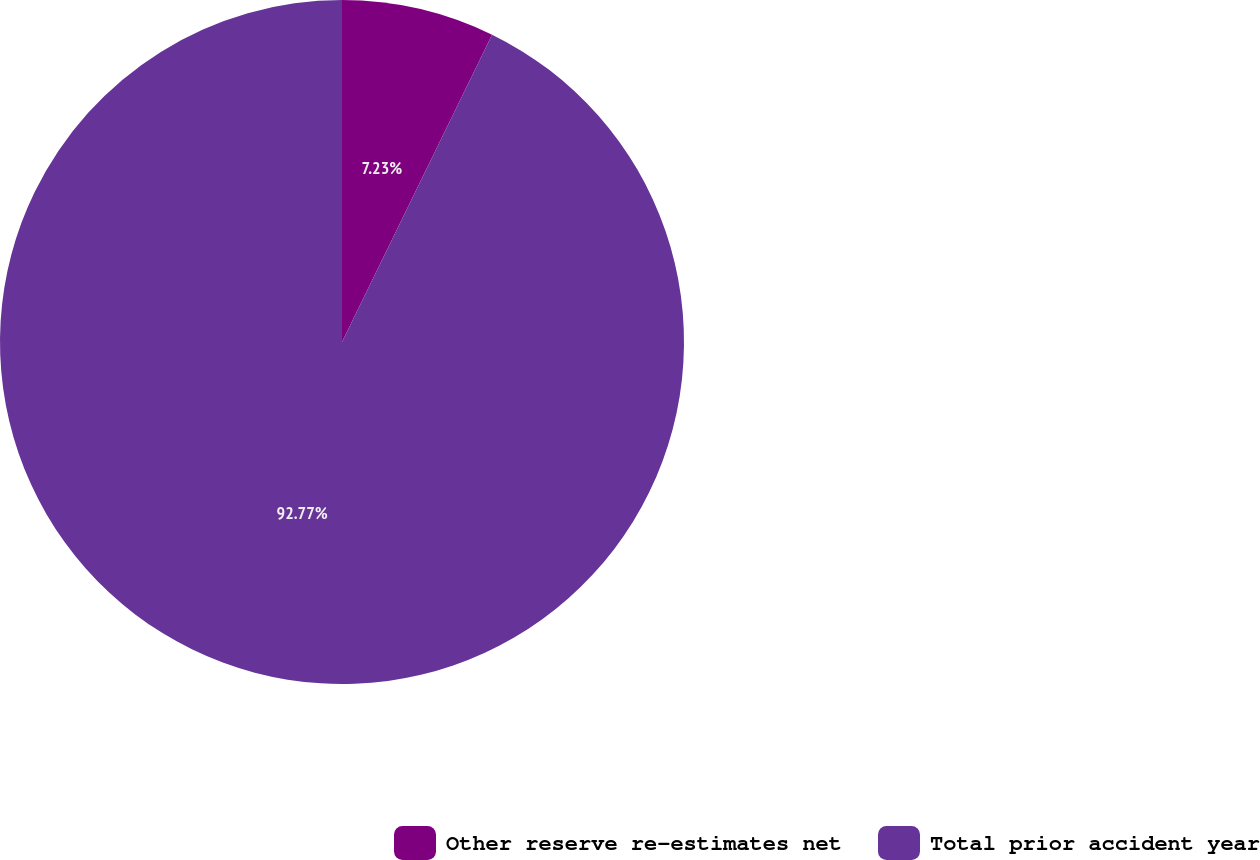Convert chart to OTSL. <chart><loc_0><loc_0><loc_500><loc_500><pie_chart><fcel>Other reserve re-estimates net<fcel>Total prior accident year<nl><fcel>7.23%<fcel>92.77%<nl></chart> 